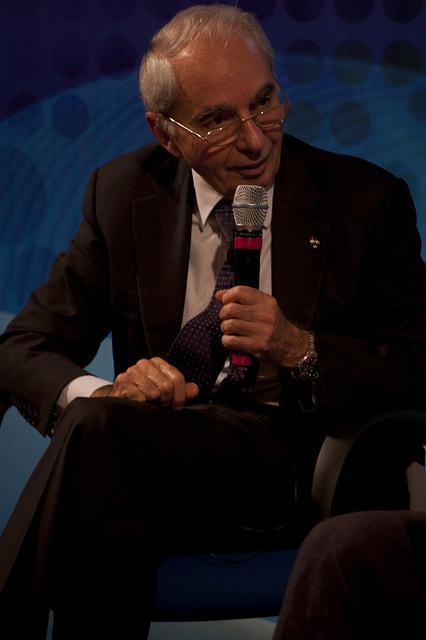How might many who listen to this speaker hear his message?
Indicate the correct choice and explain in the format: 'Answer: answer
Rationale: rationale.'
Options: Through speakers, paper, sign language, interpreter. Answer: through speakers.
Rationale: You can hear him through the speakers. 